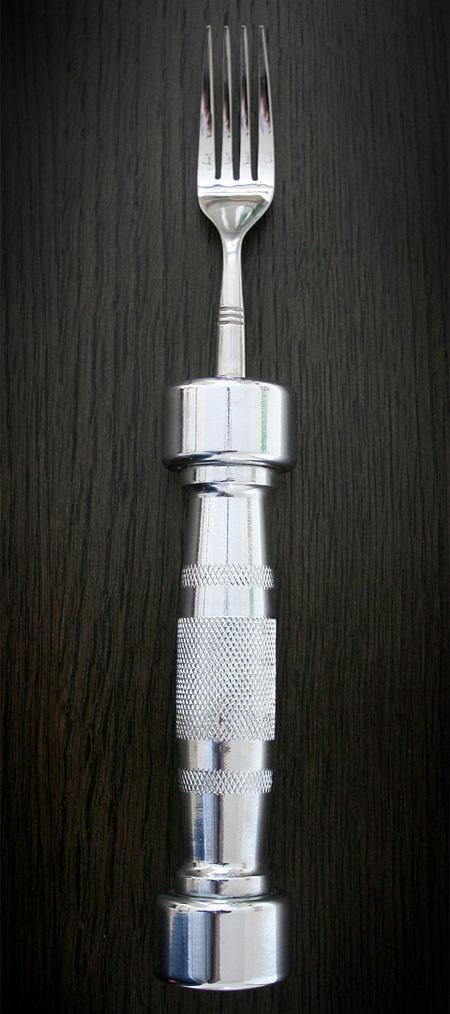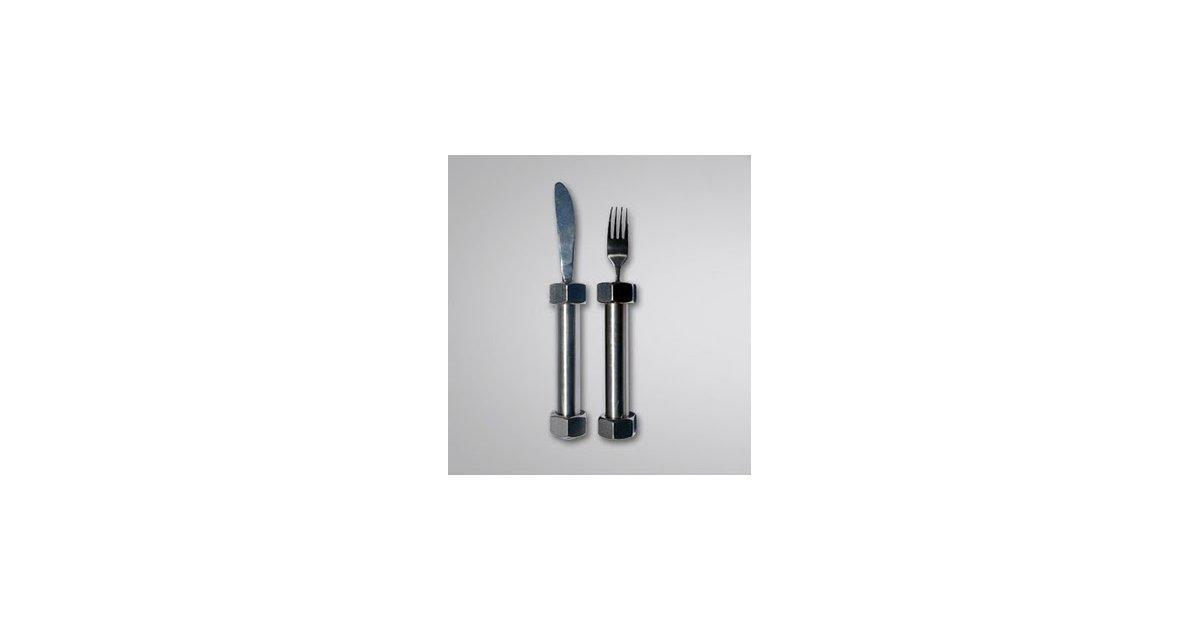The first image is the image on the left, the second image is the image on the right. Examine the images to the left and right. Is the description "One image shows a matched set of knife, fork, and spoon utensils." accurate? Answer yes or no. No. 